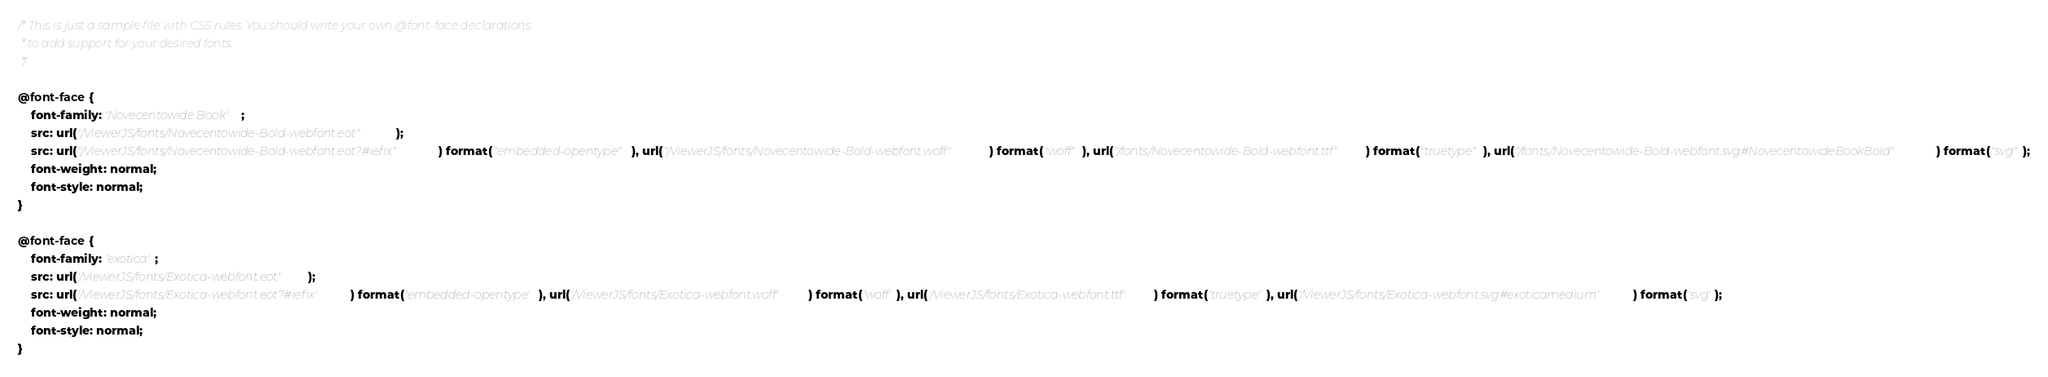<code> <loc_0><loc_0><loc_500><loc_500><_CSS_>/* This is just a sample file with CSS rules. You should write your own @font-face declarations
 * to add support for your desired fonts.
 */

@font-face {
    font-family: 'Novecentowide Book';
    src: url("/ViewerJS/fonts/Novecentowide-Bold-webfont.eot");
    src: url("/ViewerJS/fonts/Novecentowide-Bold-webfont.eot?#iefix") format("embedded-opentype"), url("/ViewerJS/fonts/Novecentowide-Bold-webfont.woff") format("woff"), url("/fonts/Novecentowide-Bold-webfont.ttf") format("truetype"), url("/fonts/Novecentowide-Bold-webfont.svg#NovecentowideBookBold") format("svg");
    font-weight: normal;
    font-style: normal;
}

@font-face {
    font-family: 'exotica';
    src: url('/ViewerJS/fonts/Exotica-webfont.eot');
    src: url('/ViewerJS/fonts/Exotica-webfont.eot?#iefix') format('embedded-opentype'), url('/ViewerJS/fonts/Exotica-webfont.woff') format('woff'), url('/ViewerJS/fonts/Exotica-webfont.ttf') format('truetype'), url('/ViewerJS/fonts/Exotica-webfont.svg#exoticamedium') format('svg');
    font-weight: normal;
    font-style: normal;
}</code> 